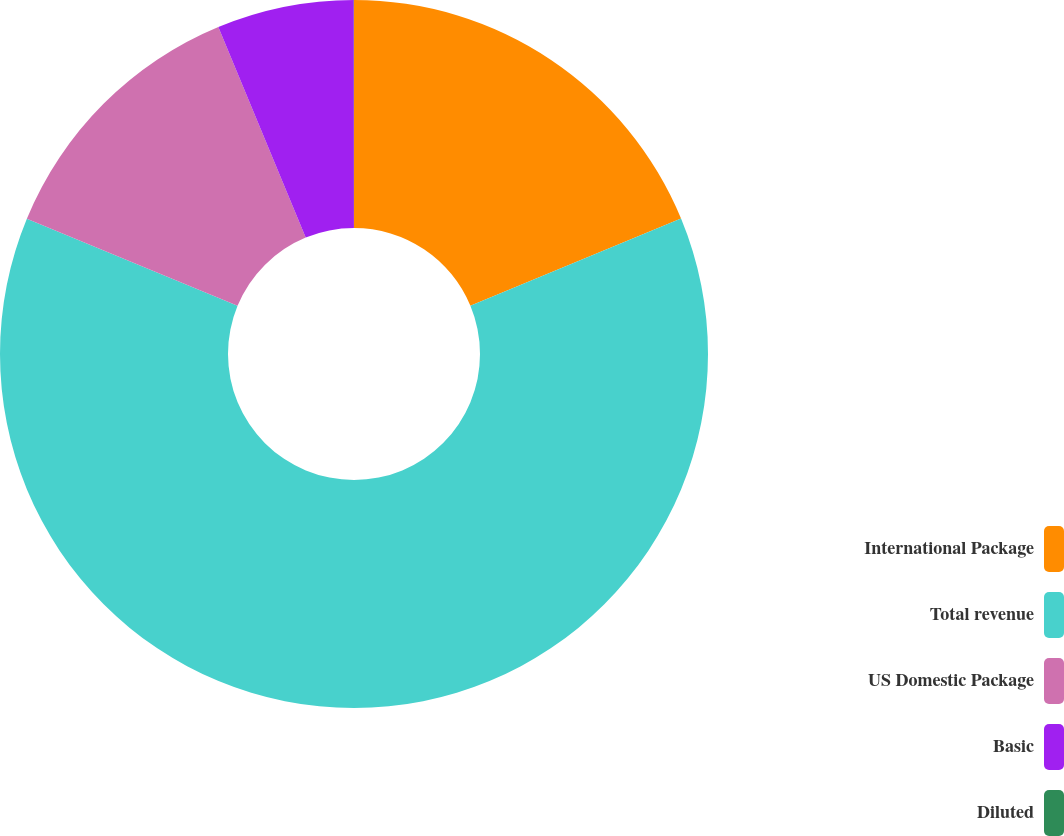<chart> <loc_0><loc_0><loc_500><loc_500><pie_chart><fcel>International Package<fcel>Total revenue<fcel>US Domestic Package<fcel>Basic<fcel>Diluted<nl><fcel>18.75%<fcel>62.49%<fcel>12.5%<fcel>6.25%<fcel>0.01%<nl></chart> 